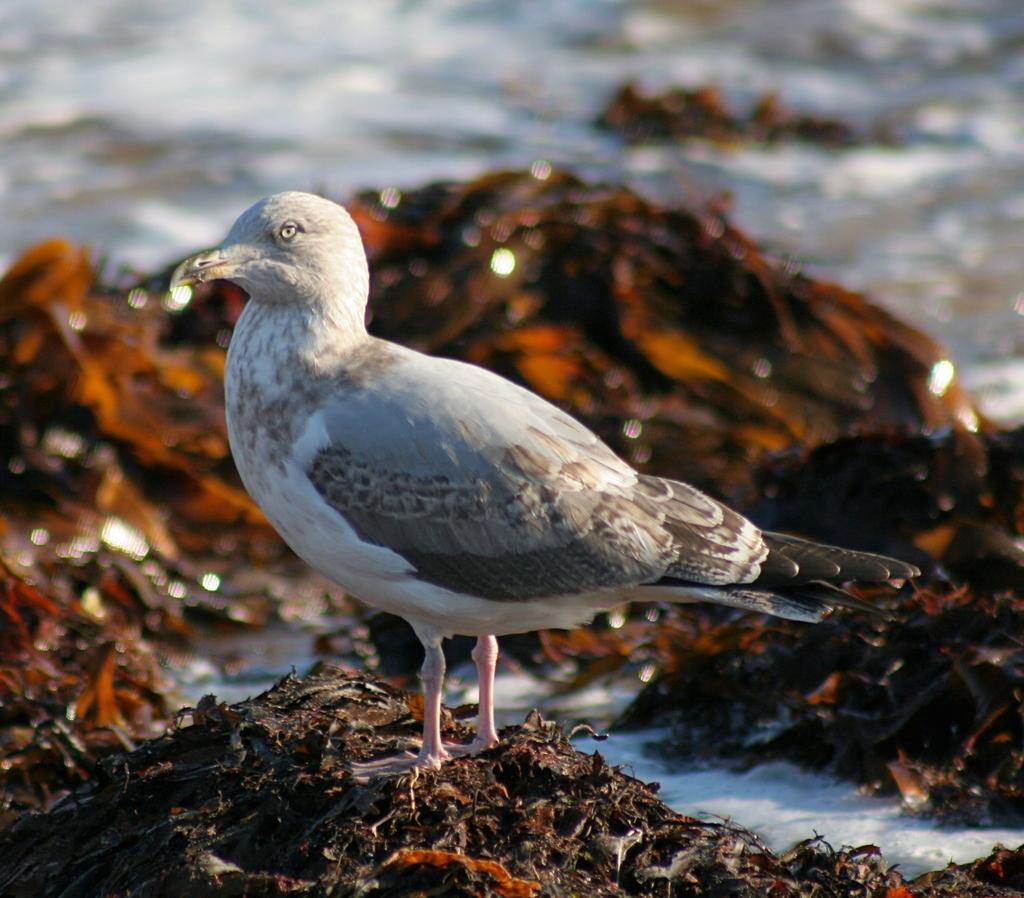What type of animal is on the ground in the image? There is a bird on the ground in the image. What can be seen in the background or surrounding the bird? There is water visible in the image. How many pigs are swimming in the water in the image? There are no pigs present in the image; it features a bird on the ground and water in the background. What type of insect can be seen crawling on the bird in the image? There is no insect, specifically a ladybug, present on the bird in the image. 